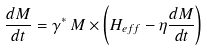<formula> <loc_0><loc_0><loc_500><loc_500>\frac { d { M } } { d t } = \gamma ^ { * } \, M \times \left ( H _ { e f f } - \eta \frac { d { M } } { d t } \right )</formula> 